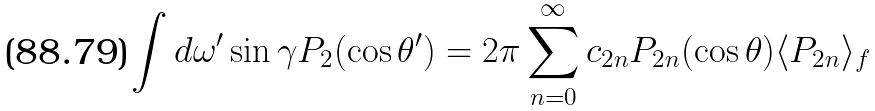Convert formula to latex. <formula><loc_0><loc_0><loc_500><loc_500>\int d \omega ^ { \prime } \sin \gamma P _ { 2 } ( \cos \theta ^ { \prime } ) = 2 \pi \sum _ { n = 0 } ^ { \infty } c _ { 2 n } P _ { 2 n } ( \cos \theta ) \langle P _ { 2 n } \rangle _ { f }</formula> 